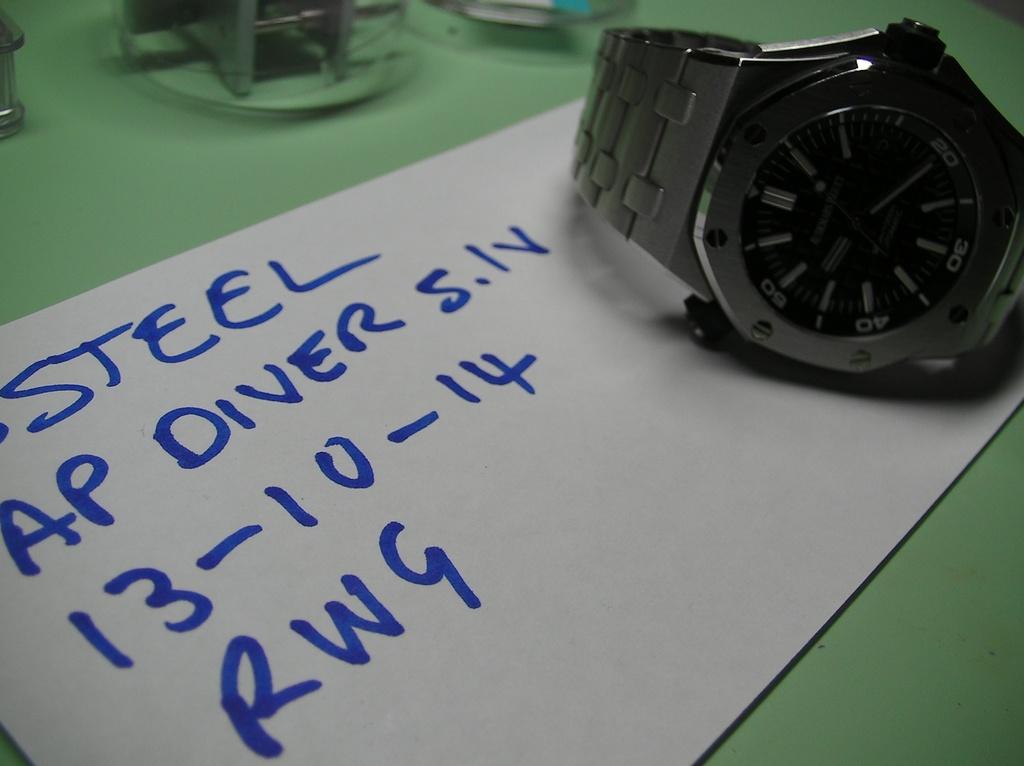What kind of metal is the watch?
Keep it short and to the point. Steel. What style of watch is shown?
Your response must be concise. Steel. 